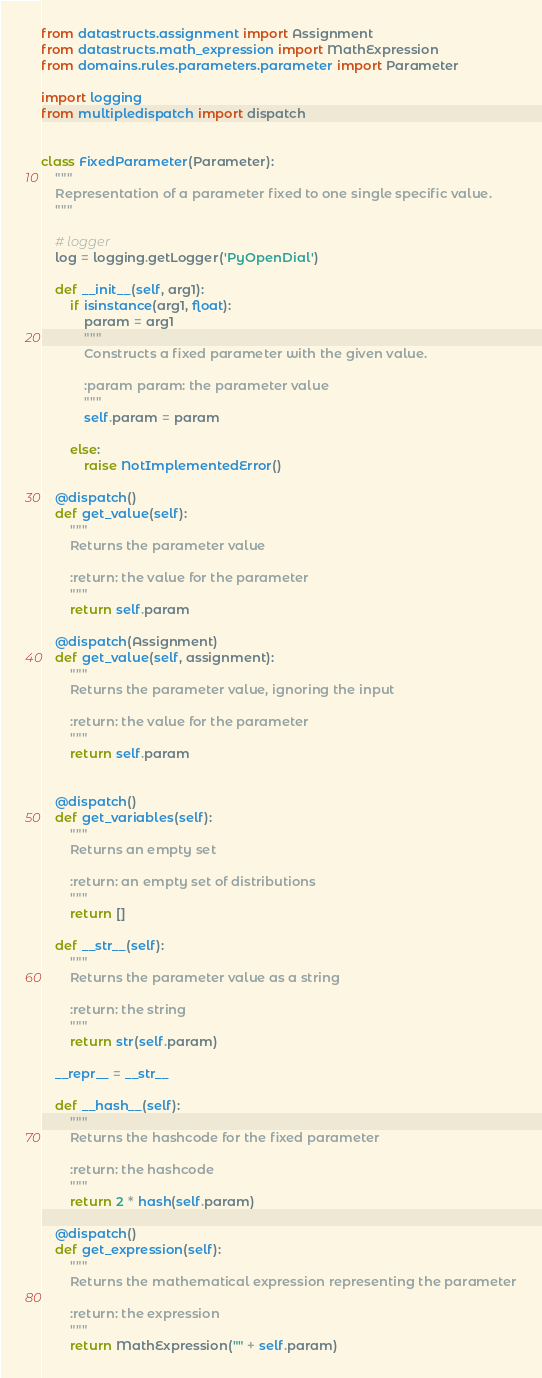<code> <loc_0><loc_0><loc_500><loc_500><_Python_>from datastructs.assignment import Assignment
from datastructs.math_expression import MathExpression
from domains.rules.parameters.parameter import Parameter

import logging
from multipledispatch import dispatch


class FixedParameter(Parameter):
    """
    Representation of a parameter fixed to one single specific value.
    """

    # logger
    log = logging.getLogger('PyOpenDial')

    def __init__(self, arg1):
        if isinstance(arg1, float):
            param = arg1
            """
            Constructs a fixed parameter with the given value.
    
            :param param: the parameter value
            """
            self.param = param

        else:
            raise NotImplementedError()

    @dispatch()
    def get_value(self):
        """
        Returns the parameter value

        :return: the value for the parameter
        """
        return self.param

    @dispatch(Assignment)
    def get_value(self, assignment):
        """
        Returns the parameter value, ignoring the input

        :return: the value for the parameter
        """
        return self.param


    @dispatch()
    def get_variables(self):
        """
        Returns an empty set

        :return: an empty set of distributions
        """
        return []

    def __str__(self):
        """
        Returns the parameter value as a string

        :return: the string
        """
        return str(self.param)

    __repr__ = __str__

    def __hash__(self):
        """
        Returns the hashcode for the fixed parameter

        :return: the hashcode
        """
        return 2 * hash(self.param)

    @dispatch()
    def get_expression(self):
        """
        Returns the mathematical expression representing the parameter

        :return: the expression
        """
        return MathExpression("" + self.param)
</code> 